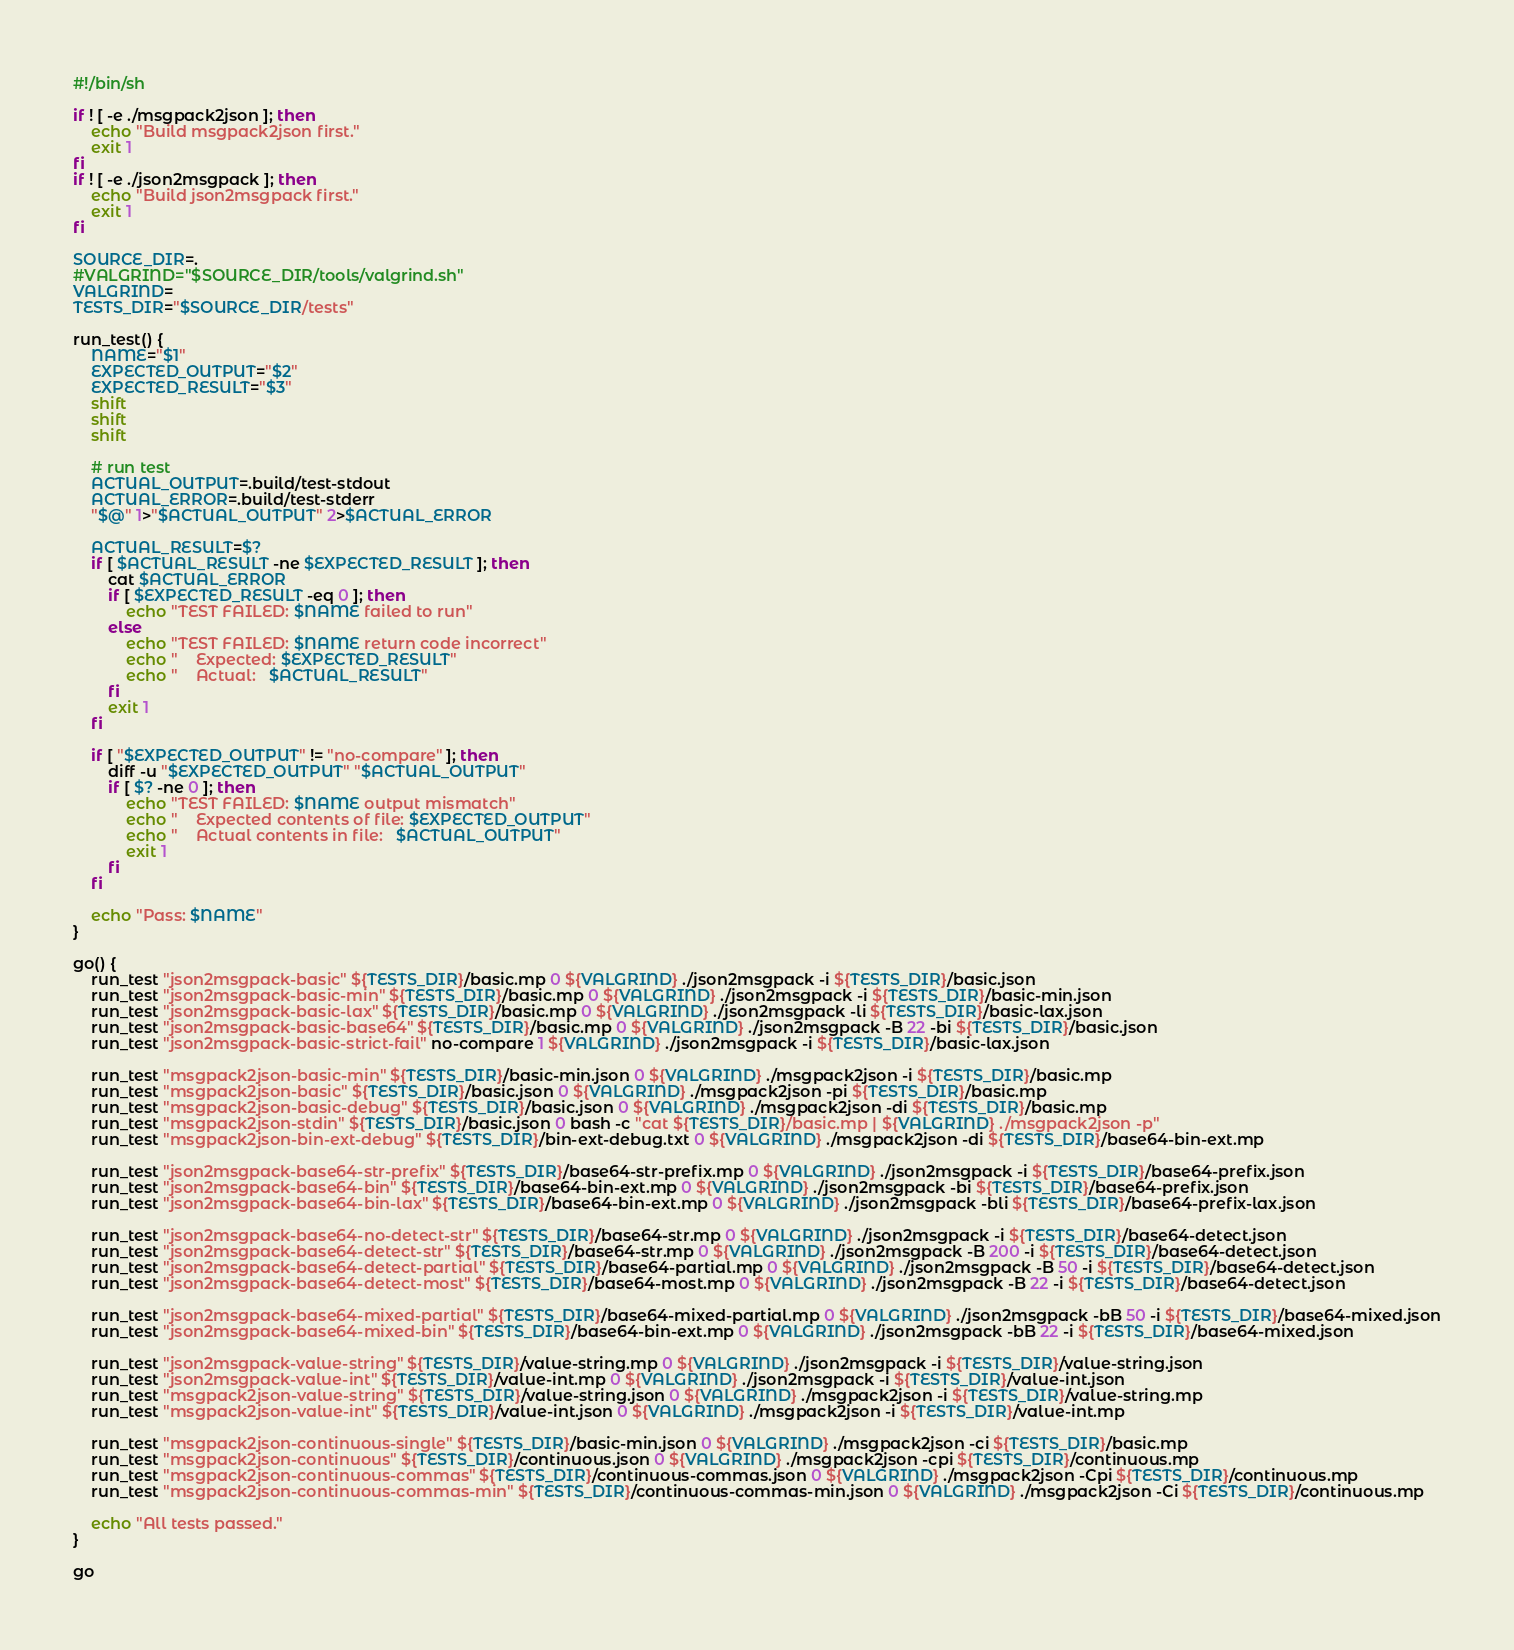Convert code to text. <code><loc_0><loc_0><loc_500><loc_500><_Bash_>#!/bin/sh

if ! [ -e ./msgpack2json ]; then
    echo "Build msgpack2json first."
    exit 1
fi
if ! [ -e ./json2msgpack ]; then
    echo "Build json2msgpack first."
    exit 1
fi

SOURCE_DIR=.
#VALGRIND="$SOURCE_DIR/tools/valgrind.sh"
VALGRIND=
TESTS_DIR="$SOURCE_DIR/tests"

run_test() {
    NAME="$1"
    EXPECTED_OUTPUT="$2"
    EXPECTED_RESULT="$3"
    shift
    shift
    shift

    # run test
    ACTUAL_OUTPUT=.build/test-stdout
    ACTUAL_ERROR=.build/test-stderr
    "$@" 1>"$ACTUAL_OUTPUT" 2>$ACTUAL_ERROR

    ACTUAL_RESULT=$?
    if [ $ACTUAL_RESULT -ne $EXPECTED_RESULT ]; then
        cat $ACTUAL_ERROR
        if [ $EXPECTED_RESULT -eq 0 ]; then
            echo "TEST FAILED: $NAME failed to run"
        else
            echo "TEST FAILED: $NAME return code incorrect"
            echo "    Expected: $EXPECTED_RESULT"
            echo "    Actual:   $ACTUAL_RESULT"
        fi
        exit 1
    fi

    if [ "$EXPECTED_OUTPUT" != "no-compare" ]; then
        diff -u "$EXPECTED_OUTPUT" "$ACTUAL_OUTPUT"
        if [ $? -ne 0 ]; then
            echo "TEST FAILED: $NAME output mismatch"
            echo "    Expected contents of file: $EXPECTED_OUTPUT"
            echo "    Actual contents in file:   $ACTUAL_OUTPUT"
            exit 1
        fi
    fi

    echo "Pass: $NAME"
}

go() {
    run_test "json2msgpack-basic" ${TESTS_DIR}/basic.mp 0 ${VALGRIND} ./json2msgpack -i ${TESTS_DIR}/basic.json
    run_test "json2msgpack-basic-min" ${TESTS_DIR}/basic.mp 0 ${VALGRIND} ./json2msgpack -i ${TESTS_DIR}/basic-min.json
    run_test "json2msgpack-basic-lax" ${TESTS_DIR}/basic.mp 0 ${VALGRIND} ./json2msgpack -li ${TESTS_DIR}/basic-lax.json
    run_test "json2msgpack-basic-base64" ${TESTS_DIR}/basic.mp 0 ${VALGRIND} ./json2msgpack -B 22 -bi ${TESTS_DIR}/basic.json
    run_test "json2msgpack-basic-strict-fail" no-compare 1 ${VALGRIND} ./json2msgpack -i ${TESTS_DIR}/basic-lax.json

    run_test "msgpack2json-basic-min" ${TESTS_DIR}/basic-min.json 0 ${VALGRIND} ./msgpack2json -i ${TESTS_DIR}/basic.mp
    run_test "msgpack2json-basic" ${TESTS_DIR}/basic.json 0 ${VALGRIND} ./msgpack2json -pi ${TESTS_DIR}/basic.mp
    run_test "msgpack2json-basic-debug" ${TESTS_DIR}/basic.json 0 ${VALGRIND} ./msgpack2json -di ${TESTS_DIR}/basic.mp
    run_test "msgpack2json-stdin" ${TESTS_DIR}/basic.json 0 bash -c "cat ${TESTS_DIR}/basic.mp | ${VALGRIND} ./msgpack2json -p"
    run_test "msgpack2json-bin-ext-debug" ${TESTS_DIR}/bin-ext-debug.txt 0 ${VALGRIND} ./msgpack2json -di ${TESTS_DIR}/base64-bin-ext.mp

    run_test "json2msgpack-base64-str-prefix" ${TESTS_DIR}/base64-str-prefix.mp 0 ${VALGRIND} ./json2msgpack -i ${TESTS_DIR}/base64-prefix.json
    run_test "json2msgpack-base64-bin" ${TESTS_DIR}/base64-bin-ext.mp 0 ${VALGRIND} ./json2msgpack -bi ${TESTS_DIR}/base64-prefix.json
    run_test "json2msgpack-base64-bin-lax" ${TESTS_DIR}/base64-bin-ext.mp 0 ${VALGRIND} ./json2msgpack -bli ${TESTS_DIR}/base64-prefix-lax.json

    run_test "json2msgpack-base64-no-detect-str" ${TESTS_DIR}/base64-str.mp 0 ${VALGRIND} ./json2msgpack -i ${TESTS_DIR}/base64-detect.json
    run_test "json2msgpack-base64-detect-str" ${TESTS_DIR}/base64-str.mp 0 ${VALGRIND} ./json2msgpack -B 200 -i ${TESTS_DIR}/base64-detect.json
    run_test "json2msgpack-base64-detect-partial" ${TESTS_DIR}/base64-partial.mp 0 ${VALGRIND} ./json2msgpack -B 50 -i ${TESTS_DIR}/base64-detect.json
    run_test "json2msgpack-base64-detect-most" ${TESTS_DIR}/base64-most.mp 0 ${VALGRIND} ./json2msgpack -B 22 -i ${TESTS_DIR}/base64-detect.json

    run_test "json2msgpack-base64-mixed-partial" ${TESTS_DIR}/base64-mixed-partial.mp 0 ${VALGRIND} ./json2msgpack -bB 50 -i ${TESTS_DIR}/base64-mixed.json
    run_test "json2msgpack-base64-mixed-bin" ${TESTS_DIR}/base64-bin-ext.mp 0 ${VALGRIND} ./json2msgpack -bB 22 -i ${TESTS_DIR}/base64-mixed.json

    run_test "json2msgpack-value-string" ${TESTS_DIR}/value-string.mp 0 ${VALGRIND} ./json2msgpack -i ${TESTS_DIR}/value-string.json
    run_test "json2msgpack-value-int" ${TESTS_DIR}/value-int.mp 0 ${VALGRIND} ./json2msgpack -i ${TESTS_DIR}/value-int.json
    run_test "msgpack2json-value-string" ${TESTS_DIR}/value-string.json 0 ${VALGRIND} ./msgpack2json -i ${TESTS_DIR}/value-string.mp
    run_test "msgpack2json-value-int" ${TESTS_DIR}/value-int.json 0 ${VALGRIND} ./msgpack2json -i ${TESTS_DIR}/value-int.mp

    run_test "msgpack2json-continuous-single" ${TESTS_DIR}/basic-min.json 0 ${VALGRIND} ./msgpack2json -ci ${TESTS_DIR}/basic.mp
    run_test "msgpack2json-continuous" ${TESTS_DIR}/continuous.json 0 ${VALGRIND} ./msgpack2json -cpi ${TESTS_DIR}/continuous.mp
    run_test "msgpack2json-continuous-commas" ${TESTS_DIR}/continuous-commas.json 0 ${VALGRIND} ./msgpack2json -Cpi ${TESTS_DIR}/continuous.mp
    run_test "msgpack2json-continuous-commas-min" ${TESTS_DIR}/continuous-commas-min.json 0 ${VALGRIND} ./msgpack2json -Ci ${TESTS_DIR}/continuous.mp

    echo "All tests passed."
}

go
</code> 